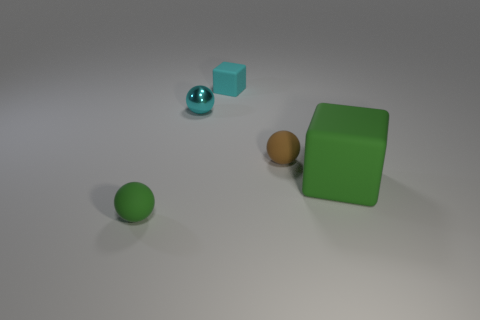Add 2 brown matte balls. How many objects exist? 7 Subtract all tiny rubber balls. How many balls are left? 1 Subtract 1 spheres. How many spheres are left? 2 Subtract all spheres. How many objects are left? 2 Add 5 brown objects. How many brown objects exist? 6 Subtract all cyan cubes. How many cubes are left? 1 Subtract 0 red cubes. How many objects are left? 5 Subtract all gray spheres. Subtract all red cubes. How many spheres are left? 3 Subtract all purple cylinders. How many blue cubes are left? 0 Subtract all big blue metallic cylinders. Subtract all tiny rubber objects. How many objects are left? 2 